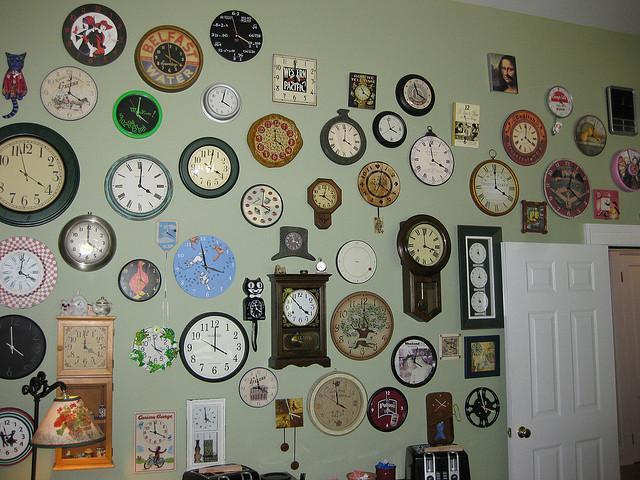How many cat clocks are there?
Give a very brief answer. 2. How many clocks can be seen?
Give a very brief answer. 7. 